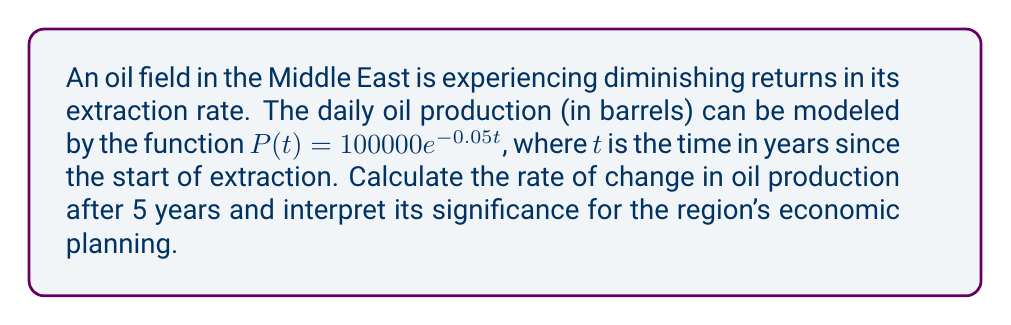What is the answer to this math problem? To solve this problem, we need to follow these steps:

1) The rate of change in oil production is given by the derivative of $P(t)$ with respect to $t$. Let's call this $P'(t)$.

2) To find $P'(t)$, we use the derivative of the exponential function:
   
   $$P'(t) = \frac{d}{dt}(100000e^{-0.05t}) = 100000 \cdot (-0.05) \cdot e^{-0.05t} = -5000e^{-0.05t}$$

3) Now, we need to evaluate $P'(t)$ at $t = 5$:
   
   $$P'(5) = -5000e^{-0.05(5)} = -5000e^{-0.25}$$

4) Using a calculator or computer:
   
   $$P'(5) \approx -3894.6$$

5) Interpretation: The negative value indicates that the production rate is decreasing. After 5 years, the oil production is decreasing at a rate of approximately 3894.6 barrels per year.

This result is significant for the region's economic planning as it indicates:

a) The need to diversify the economy away from oil dependence.
b) The importance of investing in enhanced oil recovery techniques.
c) The potential for reduced oil revenues in the future, affecting government budgets and development plans.
d) The necessity of sustainable development strategies that account for diminishing natural resources.
Answer: $-3894.6$ barrels per year 